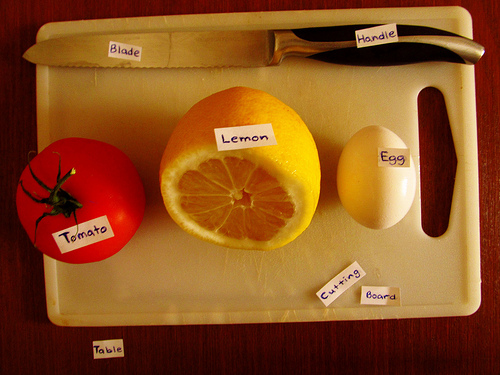<image>
Is there a tomato next to the egg? No. The tomato is not positioned next to the egg. They are located in different areas of the scene. Is the egg behind the cutting board? No. The egg is not behind the cutting board. From this viewpoint, the egg appears to be positioned elsewhere in the scene. Is the tomato on the table? Yes. Looking at the image, I can see the tomato is positioned on top of the table, with the table providing support. Is the egg to the right of the lemon? Yes. From this viewpoint, the egg is positioned to the right side relative to the lemon. 